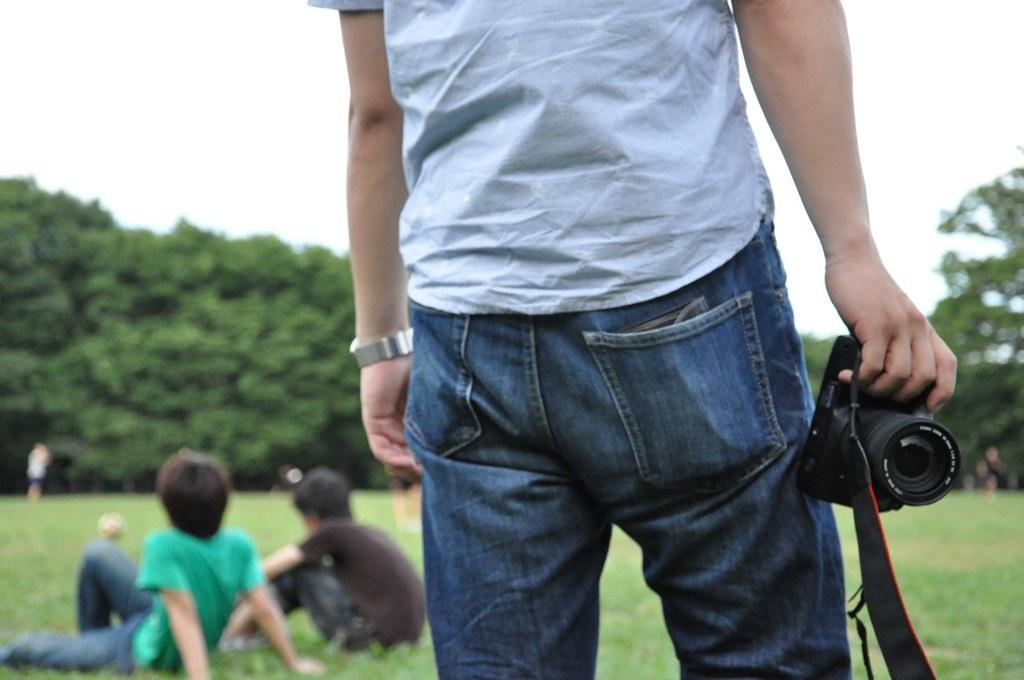What is the man in the image doing? The man is standing in the image and holding a camera in his hand. Who else is present in the image besides the man? There are two boys sitting on the grass in the image. What can be seen in the background of the image? There are many trees in the image. What is the color of the sky in the image? The sky is white in color. What language is the man speaking to the boys in the image? There is no information about the language being spoken in the image. What type of apparel is the man wearing in the image? The provided facts do not mention the man's apparel. 